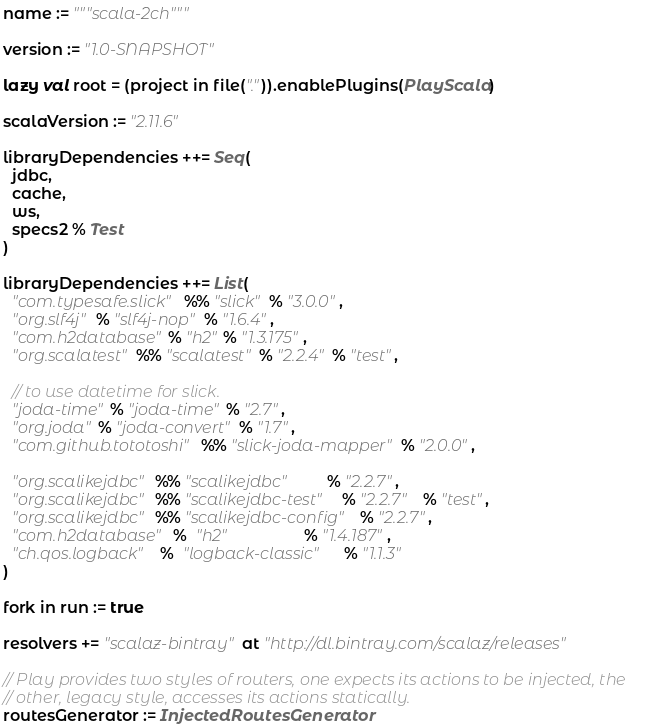<code> <loc_0><loc_0><loc_500><loc_500><_Scala_>name := """scala-2ch"""

version := "1.0-SNAPSHOT"

lazy val root = (project in file(".")).enablePlugins(PlayScala)

scalaVersion := "2.11.6"

libraryDependencies ++= Seq(
  jdbc,
  cache,
  ws,
  specs2 % Test
)

libraryDependencies ++= List(
  "com.typesafe.slick" %% "slick" % "3.0.0",
  "org.slf4j" % "slf4j-nop" % "1.6.4",
  "com.h2database" % "h2" % "1.3.175",
  "org.scalatest" %% "scalatest" % "2.2.4" % "test",

  // to use datetime for slick.
  "joda-time" % "joda-time" % "2.7",
  "org.joda" % "joda-convert" % "1.7",
  "com.github.tototoshi" %% "slick-joda-mapper" % "2.0.0",

  "org.scalikejdbc" %% "scalikejdbc"        % "2.2.7",
  "org.scalikejdbc" %% "scalikejdbc-test"   % "2.2.7"   % "test",
  "org.scalikejdbc" %% "scalikejdbc-config"  % "2.2.7",
  "com.h2database"  %  "h2"                 % "1.4.187",
  "ch.qos.logback"  %  "logback-classic"    % "1.1.3"
)

fork in run := true

resolvers += "scalaz-bintray" at "http://dl.bintray.com/scalaz/releases"

// Play provides two styles of routers, one expects its actions to be injected, the
// other, legacy style, accesses its actions statically.
routesGenerator := InjectedRoutesGenerator
</code> 